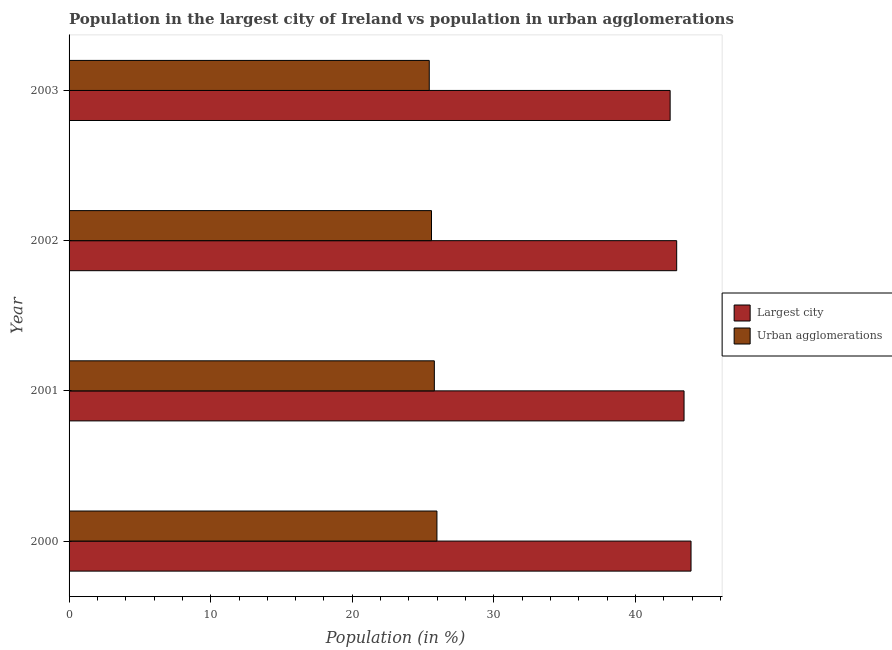How many bars are there on the 4th tick from the top?
Provide a succinct answer. 2. What is the population in the largest city in 2003?
Your answer should be very brief. 42.45. Across all years, what is the maximum population in urban agglomerations?
Offer a very short reply. 25.98. Across all years, what is the minimum population in urban agglomerations?
Your answer should be very brief. 25.44. In which year was the population in the largest city minimum?
Provide a short and direct response. 2003. What is the total population in urban agglomerations in the graph?
Make the answer very short. 102.81. What is the difference between the population in the largest city in 2000 and that in 2003?
Your response must be concise. 1.48. What is the difference between the population in urban agglomerations in 2002 and the population in the largest city in 2003?
Your response must be concise. -16.85. What is the average population in urban agglomerations per year?
Your answer should be very brief. 25.7. In the year 2002, what is the difference between the population in urban agglomerations and population in the largest city?
Give a very brief answer. -17.31. Is the difference between the population in urban agglomerations in 2002 and 2003 greater than the difference between the population in the largest city in 2002 and 2003?
Make the answer very short. No. What is the difference between the highest and the second highest population in the largest city?
Ensure brevity in your answer.  0.49. What is the difference between the highest and the lowest population in the largest city?
Give a very brief answer. 1.48. In how many years, is the population in the largest city greater than the average population in the largest city taken over all years?
Make the answer very short. 2. What does the 2nd bar from the top in 2003 represents?
Give a very brief answer. Largest city. What does the 2nd bar from the bottom in 2003 represents?
Provide a succinct answer. Urban agglomerations. How many years are there in the graph?
Give a very brief answer. 4. Are the values on the major ticks of X-axis written in scientific E-notation?
Give a very brief answer. No. Does the graph contain any zero values?
Ensure brevity in your answer.  No. How many legend labels are there?
Provide a short and direct response. 2. What is the title of the graph?
Give a very brief answer. Population in the largest city of Ireland vs population in urban agglomerations. Does "Import" appear as one of the legend labels in the graph?
Your answer should be compact. No. What is the label or title of the X-axis?
Offer a very short reply. Population (in %). What is the label or title of the Y-axis?
Offer a very short reply. Year. What is the Population (in %) of Largest city in 2000?
Provide a succinct answer. 43.92. What is the Population (in %) of Urban agglomerations in 2000?
Offer a terse response. 25.98. What is the Population (in %) of Largest city in 2001?
Give a very brief answer. 43.43. What is the Population (in %) of Urban agglomerations in 2001?
Offer a terse response. 25.8. What is the Population (in %) in Largest city in 2002?
Your answer should be very brief. 42.91. What is the Population (in %) in Urban agglomerations in 2002?
Your answer should be compact. 25.6. What is the Population (in %) in Largest city in 2003?
Provide a succinct answer. 42.45. What is the Population (in %) in Urban agglomerations in 2003?
Give a very brief answer. 25.44. Across all years, what is the maximum Population (in %) in Largest city?
Your response must be concise. 43.92. Across all years, what is the maximum Population (in %) in Urban agglomerations?
Offer a very short reply. 25.98. Across all years, what is the minimum Population (in %) in Largest city?
Provide a succinct answer. 42.45. Across all years, what is the minimum Population (in %) in Urban agglomerations?
Keep it short and to the point. 25.44. What is the total Population (in %) in Largest city in the graph?
Offer a very short reply. 172.71. What is the total Population (in %) of Urban agglomerations in the graph?
Give a very brief answer. 102.81. What is the difference between the Population (in %) of Largest city in 2000 and that in 2001?
Give a very brief answer. 0.49. What is the difference between the Population (in %) in Urban agglomerations in 2000 and that in 2001?
Make the answer very short. 0.18. What is the difference between the Population (in %) in Largest city in 2000 and that in 2002?
Your answer should be compact. 1.01. What is the difference between the Population (in %) of Urban agglomerations in 2000 and that in 2002?
Your answer should be very brief. 0.38. What is the difference between the Population (in %) of Largest city in 2000 and that in 2003?
Ensure brevity in your answer.  1.48. What is the difference between the Population (in %) in Urban agglomerations in 2000 and that in 2003?
Your answer should be compact. 0.54. What is the difference between the Population (in %) of Largest city in 2001 and that in 2002?
Your answer should be compact. 0.52. What is the difference between the Population (in %) of Urban agglomerations in 2001 and that in 2002?
Give a very brief answer. 0.2. What is the difference between the Population (in %) of Largest city in 2001 and that in 2003?
Ensure brevity in your answer.  0.98. What is the difference between the Population (in %) of Urban agglomerations in 2001 and that in 2003?
Provide a succinct answer. 0.36. What is the difference between the Population (in %) in Largest city in 2002 and that in 2003?
Make the answer very short. 0.46. What is the difference between the Population (in %) in Urban agglomerations in 2002 and that in 2003?
Offer a very short reply. 0.16. What is the difference between the Population (in %) of Largest city in 2000 and the Population (in %) of Urban agglomerations in 2001?
Your answer should be very brief. 18.13. What is the difference between the Population (in %) of Largest city in 2000 and the Population (in %) of Urban agglomerations in 2002?
Make the answer very short. 18.33. What is the difference between the Population (in %) in Largest city in 2000 and the Population (in %) in Urban agglomerations in 2003?
Your answer should be very brief. 18.49. What is the difference between the Population (in %) in Largest city in 2001 and the Population (in %) in Urban agglomerations in 2002?
Your response must be concise. 17.84. What is the difference between the Population (in %) in Largest city in 2001 and the Population (in %) in Urban agglomerations in 2003?
Offer a terse response. 17.99. What is the difference between the Population (in %) in Largest city in 2002 and the Population (in %) in Urban agglomerations in 2003?
Offer a very short reply. 17.47. What is the average Population (in %) in Largest city per year?
Your response must be concise. 43.18. What is the average Population (in %) in Urban agglomerations per year?
Your answer should be very brief. 25.7. In the year 2000, what is the difference between the Population (in %) in Largest city and Population (in %) in Urban agglomerations?
Your answer should be compact. 17.94. In the year 2001, what is the difference between the Population (in %) of Largest city and Population (in %) of Urban agglomerations?
Provide a succinct answer. 17.63. In the year 2002, what is the difference between the Population (in %) of Largest city and Population (in %) of Urban agglomerations?
Keep it short and to the point. 17.31. In the year 2003, what is the difference between the Population (in %) of Largest city and Population (in %) of Urban agglomerations?
Make the answer very short. 17.01. What is the ratio of the Population (in %) of Largest city in 2000 to that in 2001?
Make the answer very short. 1.01. What is the ratio of the Population (in %) in Urban agglomerations in 2000 to that in 2001?
Your answer should be very brief. 1.01. What is the ratio of the Population (in %) in Largest city in 2000 to that in 2002?
Keep it short and to the point. 1.02. What is the ratio of the Population (in %) of Urban agglomerations in 2000 to that in 2002?
Provide a succinct answer. 1.01. What is the ratio of the Population (in %) of Largest city in 2000 to that in 2003?
Make the answer very short. 1.03. What is the ratio of the Population (in %) of Urban agglomerations in 2000 to that in 2003?
Ensure brevity in your answer.  1.02. What is the ratio of the Population (in %) of Largest city in 2001 to that in 2002?
Your response must be concise. 1.01. What is the ratio of the Population (in %) in Urban agglomerations in 2001 to that in 2002?
Provide a short and direct response. 1.01. What is the ratio of the Population (in %) of Largest city in 2001 to that in 2003?
Your response must be concise. 1.02. What is the ratio of the Population (in %) in Urban agglomerations in 2001 to that in 2003?
Offer a terse response. 1.01. What is the ratio of the Population (in %) in Largest city in 2002 to that in 2003?
Provide a short and direct response. 1.01. What is the difference between the highest and the second highest Population (in %) of Largest city?
Ensure brevity in your answer.  0.49. What is the difference between the highest and the second highest Population (in %) in Urban agglomerations?
Your answer should be compact. 0.18. What is the difference between the highest and the lowest Population (in %) of Largest city?
Offer a very short reply. 1.48. What is the difference between the highest and the lowest Population (in %) in Urban agglomerations?
Make the answer very short. 0.54. 